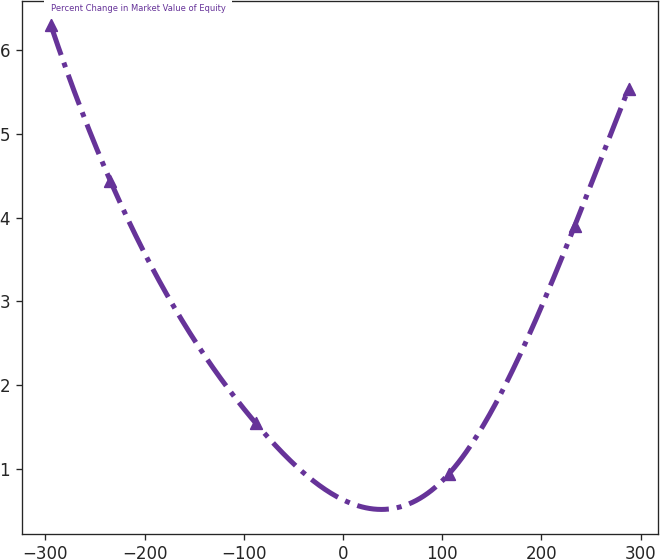Convert chart. <chart><loc_0><loc_0><loc_500><loc_500><line_chart><ecel><fcel>Percent Change in Market Value of Equity<nl><fcel>-294.7<fcel>6.3<nl><fcel>-234.63<fcel>4.44<nl><fcel>-88.13<fcel>1.55<nl><fcel>106.47<fcel>0.94<nl><fcel>233.46<fcel>3.9<nl><fcel>287.88<fcel>5.54<nl></chart> 